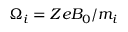Convert formula to latex. <formula><loc_0><loc_0><loc_500><loc_500>\Omega _ { i } = Z e B _ { 0 } / m _ { i }</formula> 